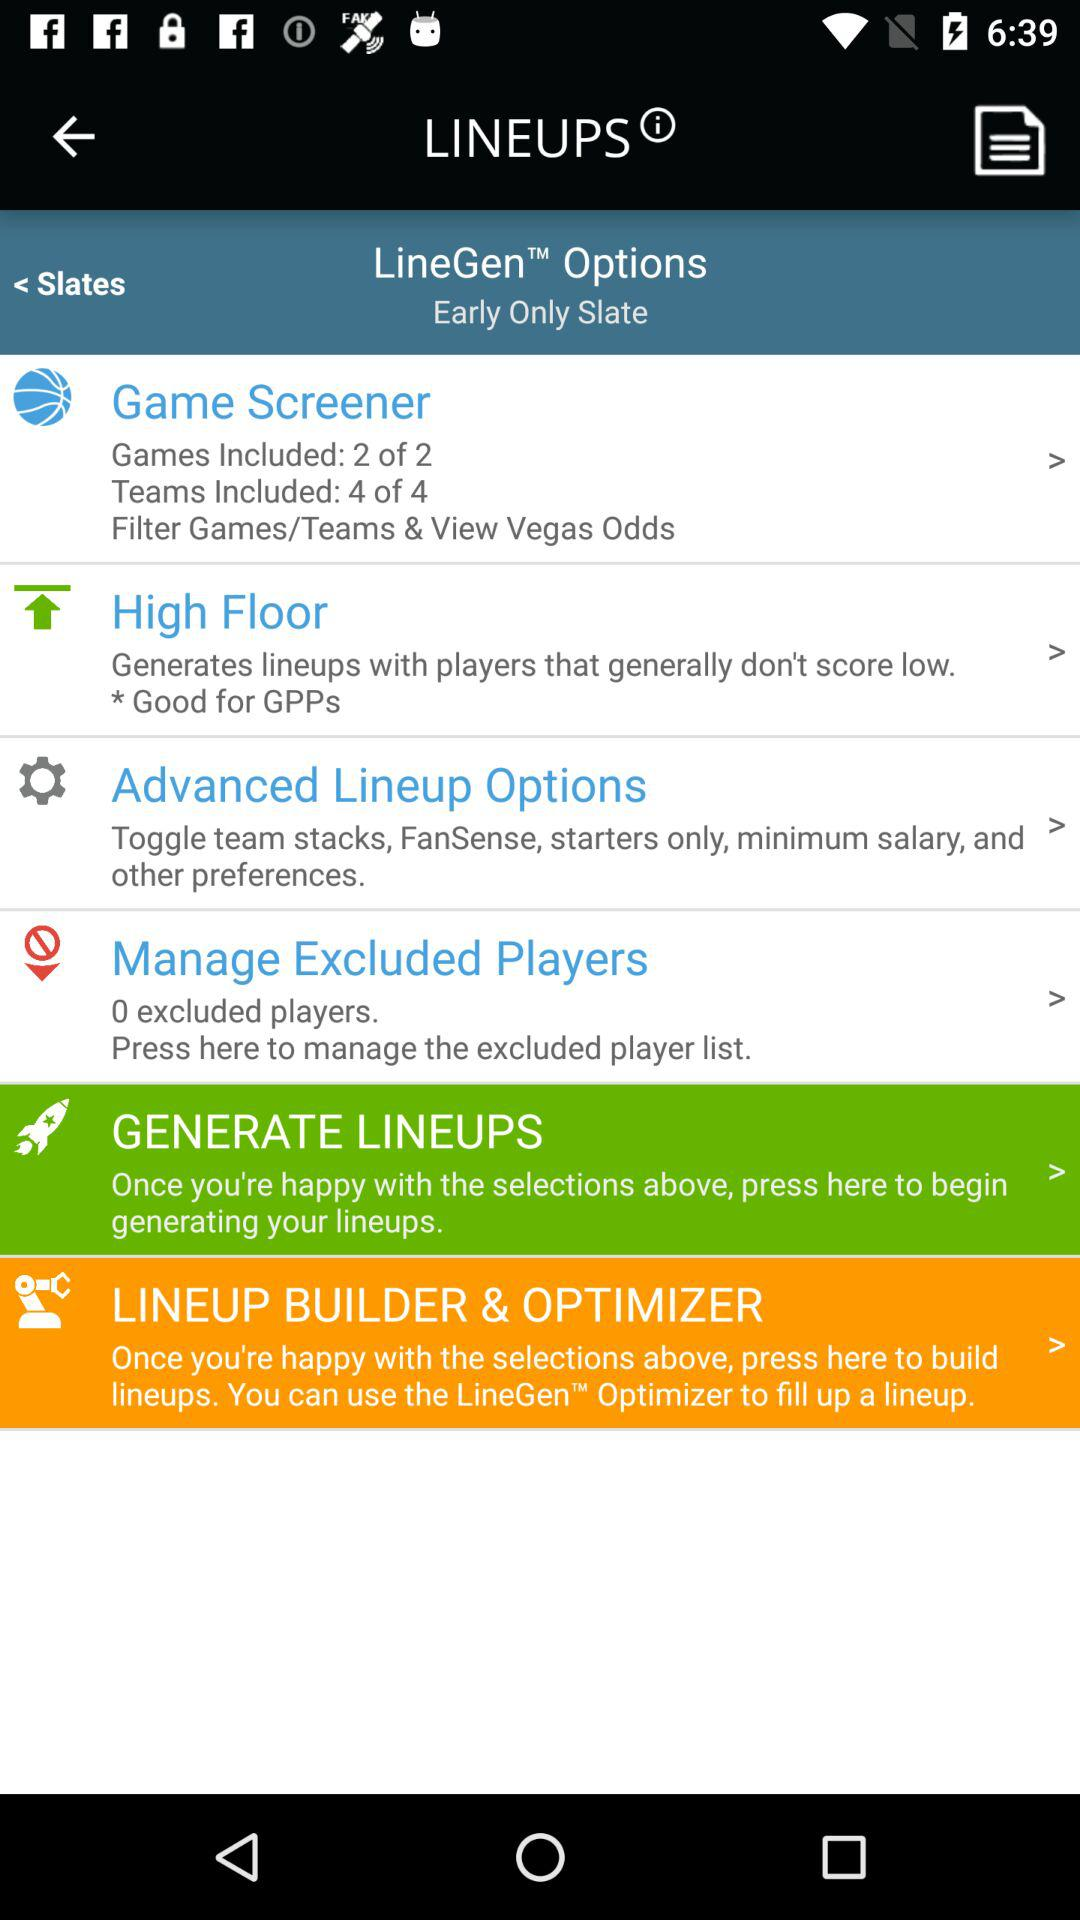What is the description given for "Advance Lineup Options"? The descriptions is "Toggle team stacks, FanSense, starters only, minimum salary, and other preferences.". 